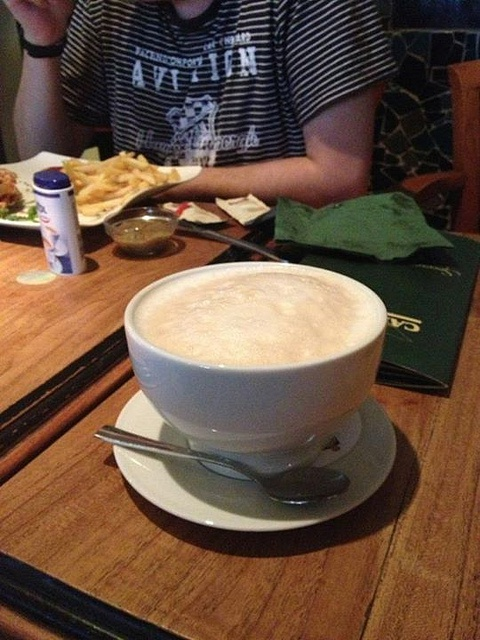Describe the objects in this image and their specific colors. I can see dining table in black, brown, maroon, and tan tones, people in black, gray, maroon, and brown tones, bowl in black, tan, gray, beige, and maroon tones, chair in maroon and black tones, and spoon in black, gray, maroon, and darkgray tones in this image. 